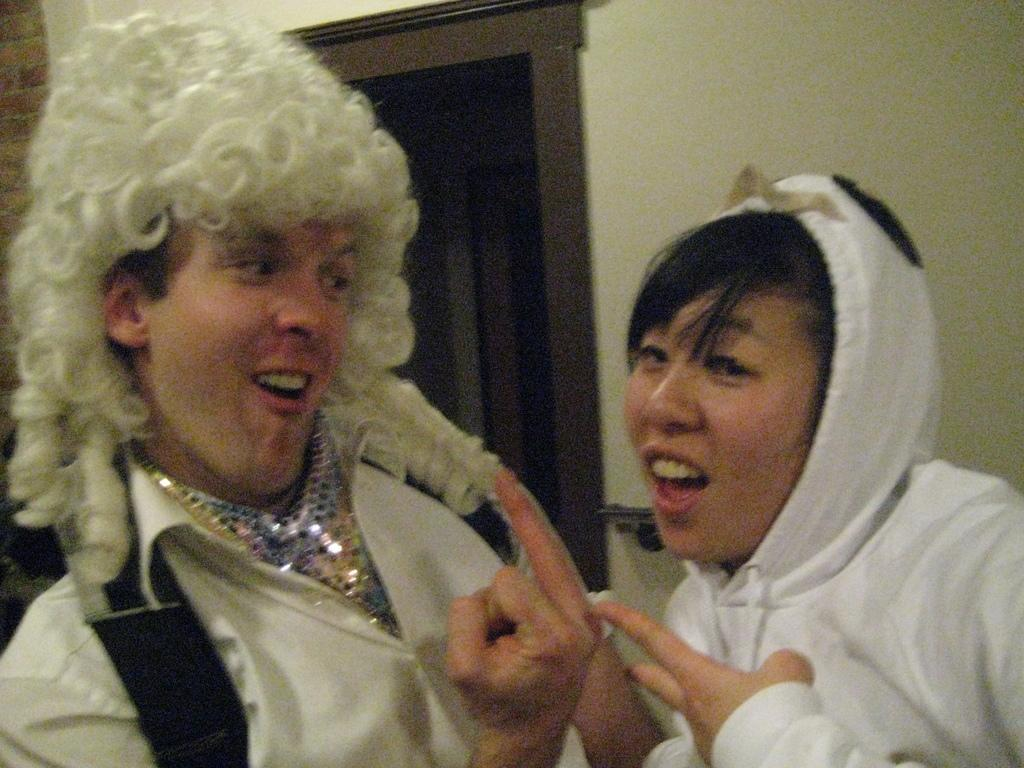Who are the people in the image? There is a man and a lady in the image. What are the man and lady doing in the image? The man and lady are standing. What can be seen in the background of the image? There is a wall and a door in the background of the image. Can you see any mountains in the image? There are no mountains visible in the image. Are there any ants crawling on the man or lady in the image? There are no ants present in the image. 